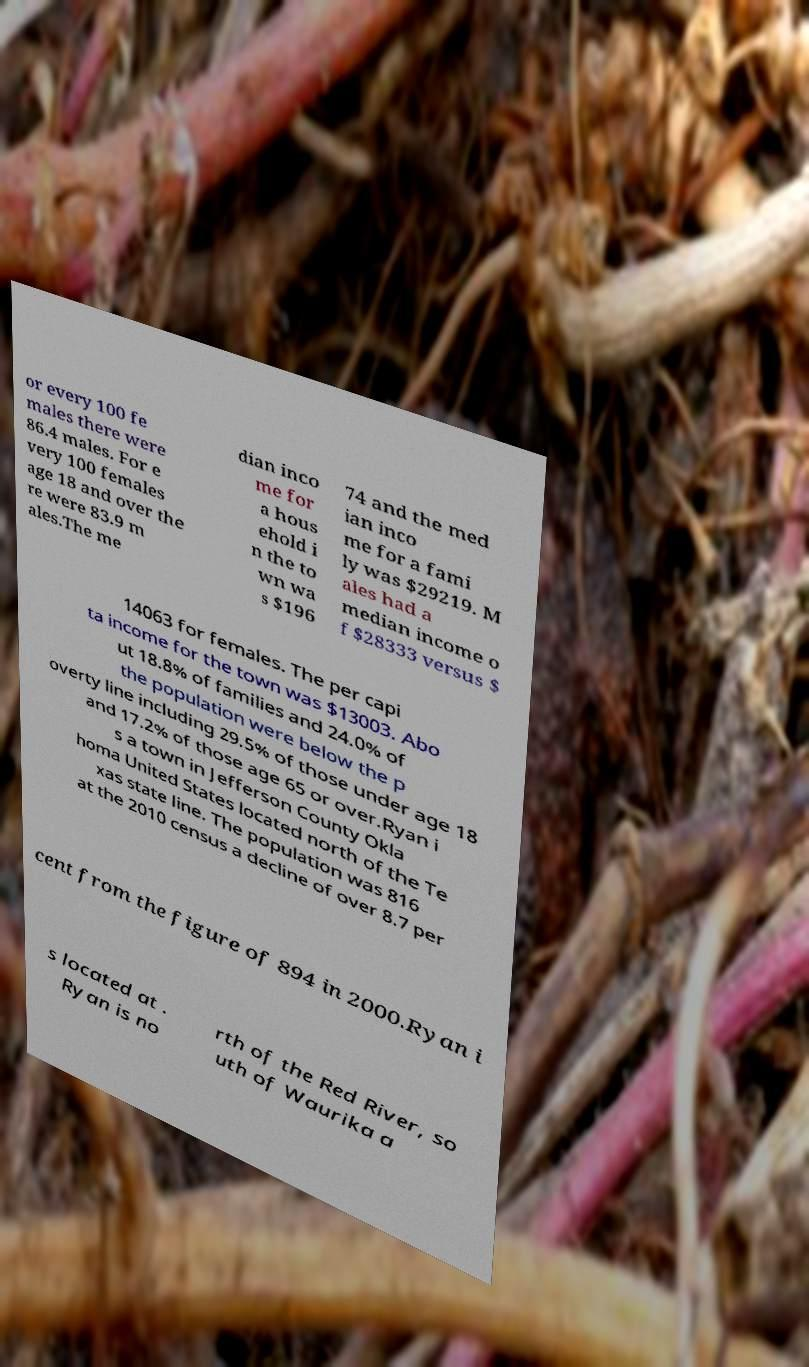For documentation purposes, I need the text within this image transcribed. Could you provide that? or every 100 fe males there were 86.4 males. For e very 100 females age 18 and over the re were 83.9 m ales.The me dian inco me for a hous ehold i n the to wn wa s $196 74 and the med ian inco me for a fami ly was $29219. M ales had a median income o f $28333 versus $ 14063 for females. The per capi ta income for the town was $13003. Abo ut 18.8% of families and 24.0% of the population were below the p overty line including 29.5% of those under age 18 and 17.2% of those age 65 or over.Ryan i s a town in Jefferson County Okla homa United States located north of the Te xas state line. The population was 816 at the 2010 census a decline of over 8.7 per cent from the figure of 894 in 2000.Ryan i s located at . Ryan is no rth of the Red River, so uth of Waurika a 